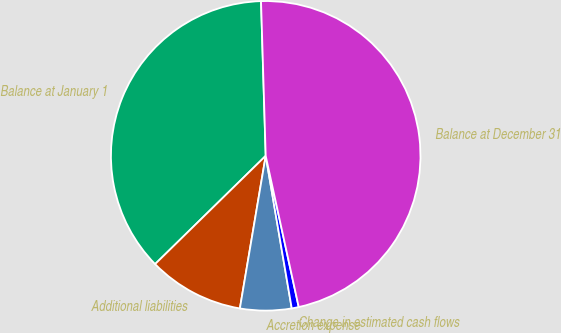Convert chart. <chart><loc_0><loc_0><loc_500><loc_500><pie_chart><fcel>Balance at January 1<fcel>Additional liabilities<fcel>Accretion expense<fcel>Change in estimated cash flows<fcel>Balance at December 31<nl><fcel>36.85%<fcel>10.0%<fcel>5.36%<fcel>0.73%<fcel>47.06%<nl></chart> 